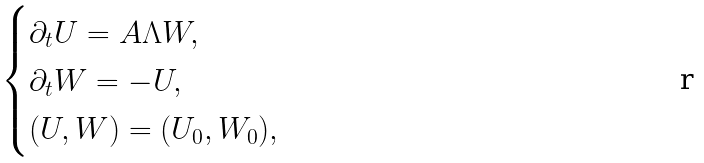<formula> <loc_0><loc_0><loc_500><loc_500>\begin{cases} \partial _ { t } U = A \Lambda W , \\ \partial _ { t } W = - U , \\ ( U , W ) = ( U _ { 0 } , W _ { 0 } ) , \end{cases}</formula> 